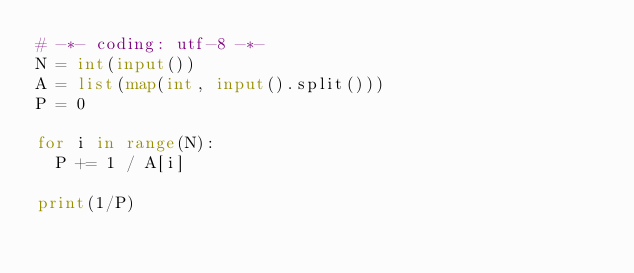Convert code to text. <code><loc_0><loc_0><loc_500><loc_500><_Python_># -*- coding: utf-8 -*-
N = int(input())
A = list(map(int, input().split()))
P = 0

for i in range(N):
	P += 1 / A[i]

print(1/P)</code> 